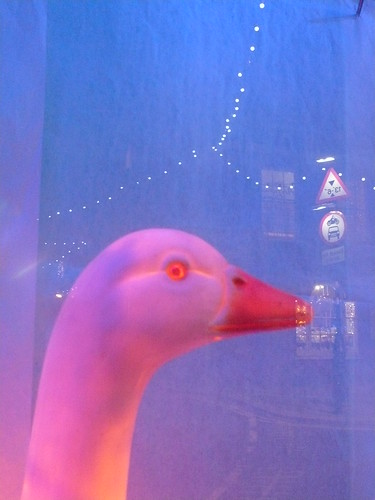Your goal is to classify the image based on its domain, which can be 'videogame', 'painting', 'sketch', 'cartoon', 'art', 'toy', 'deviantart', 'graphic', 'sculpture', 'misc', 'embroidery', 'sticker', 'graffiti', 'origami', or 'tattoo'. Your final output should specify the identified domain of the image. Based on the image's characteristics, the most fitting domain for this image is 'toy'. The realistic details and the material suggest that it is likely a model or a figure designed for display or play, rather than a living creature. The presence of the warning sign in the background, although blurred, implies that this object could be part of a themed set-up or playground where such signs are common. The artificial nature of the goose, combined with the setting, does not align with domains like 'videogame', 'painting', 'sketch', 'cartoon', 'art', 'deviantart', 'graphic', 'sculpture', 'misc', 'embroidery', 'sticker', 'graffiti', 'origami', or 'tattoo', which are typically associated with 2D visual arts, digital media, or specific crafting techniques. Therefore, the identified domain of the image is 'toy'. 